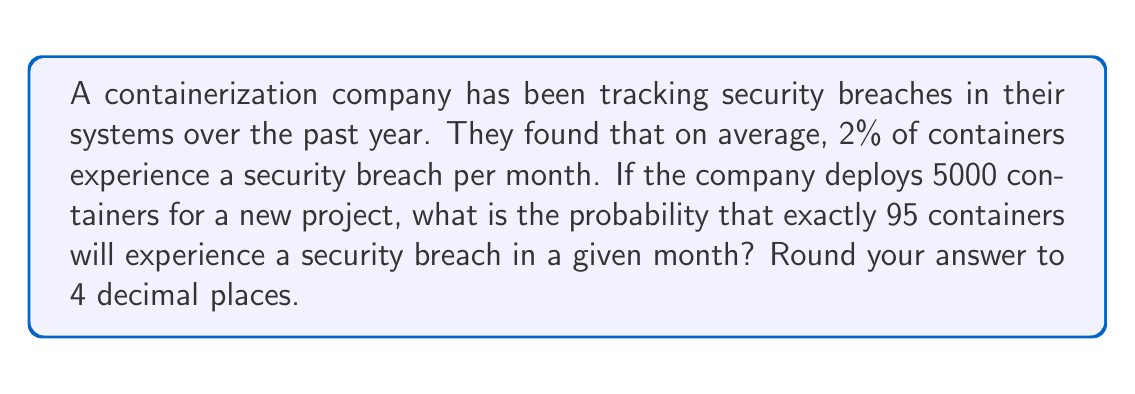Can you solve this math problem? To solve this problem, we'll use the Binomial Probability Distribution, as we're dealing with a fixed number of independent trials (containers) with two possible outcomes (breach or no breach).

The probability mass function for the Binomial Distribution is:

$$P(X = k) = \binom{n}{k} p^k (1-p)^{n-k}$$

Where:
$n$ = number of trials (containers)
$k$ = number of successes (breaches)
$p$ = probability of success on each trial

Given:
$n = 5000$ (containers)
$k = 95$ (breaches)
$p = 0.02$ (2% chance of breach per container)

Step 1: Calculate the binomial coefficient
$$\binom{5000}{95} = \frac{5000!}{95!(5000-95)!}$$

Step 2: Substitute values into the probability mass function
$$P(X = 95) = \binom{5000}{95} (0.02)^{95} (1-0.02)^{5000-95}$$

Step 3: Simplify
$$P(X = 95) = \binom{5000}{95} (0.02)^{95} (0.98)^{4905}$$

Step 4: Calculate using a calculator or computer (due to large numbers)
$$P(X = 95) \approx 0.0456$$

Step 5: Round to 4 decimal places
$$P(X = 95) \approx 0.0456$$
Answer: 0.0456 